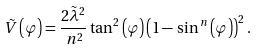<formula> <loc_0><loc_0><loc_500><loc_500>\, \tilde { V } \left ( \varphi \right ) = \frac { 2 \tilde { \lambda } ^ { 2 } } { \, n ^ { 2 } } \tan ^ { 2 } \left ( \varphi \right ) \left ( 1 - \, \sin ^ { \, n } \left ( \varphi \right ) \right ) ^ { 2 } .</formula> 